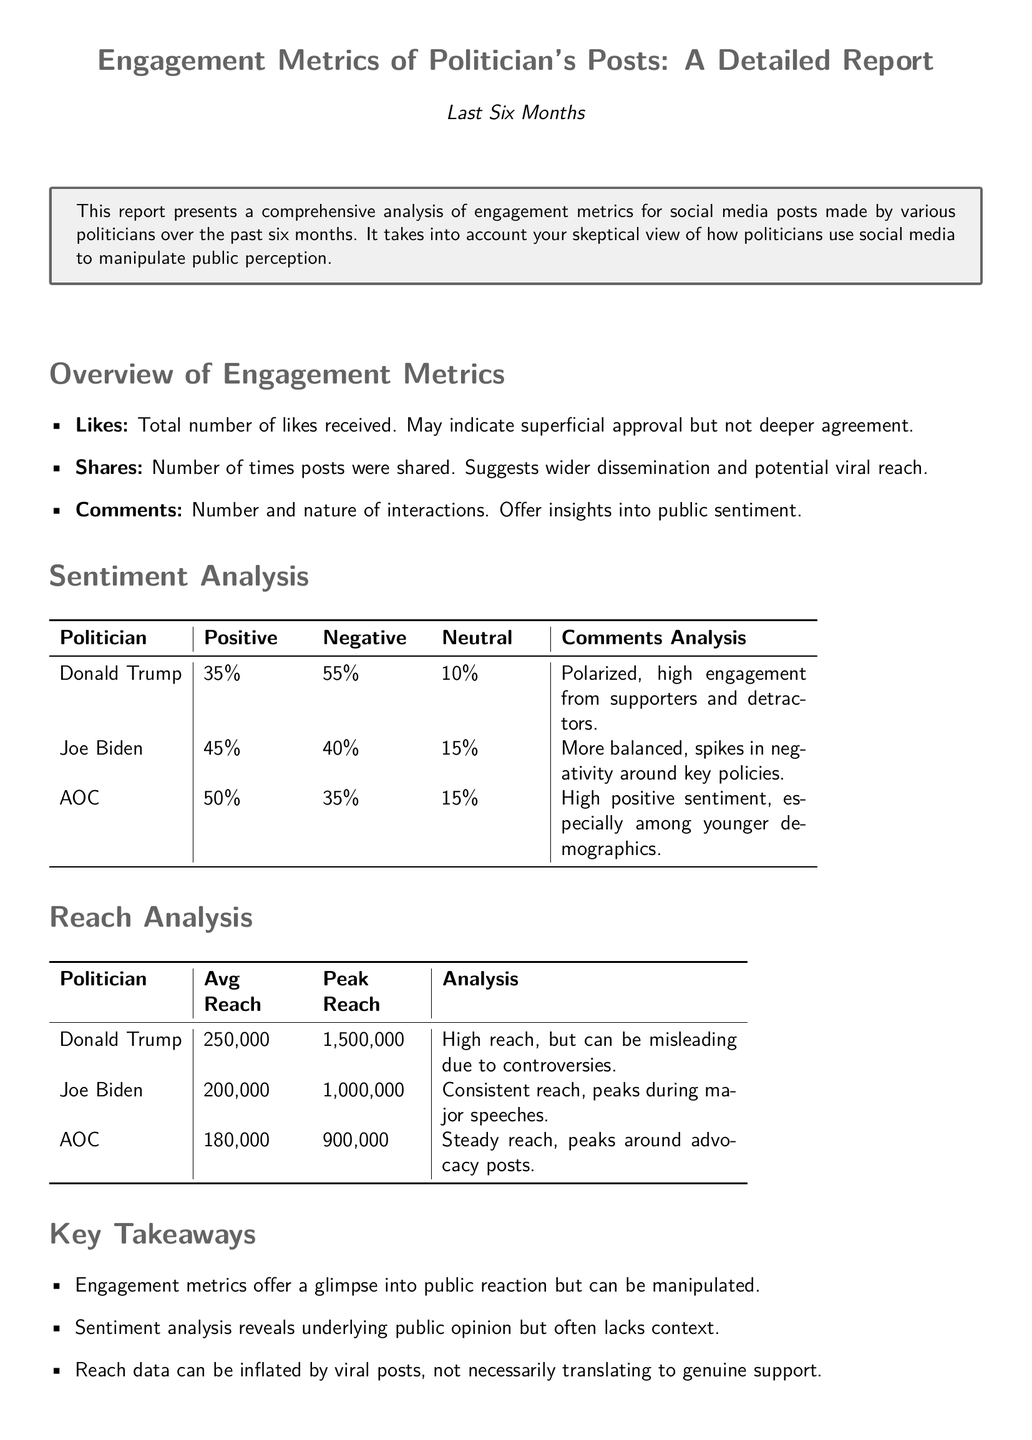what is the total percentage of positive sentiment for Joe Biden? The document states that Joe Biden has a positive sentiment of 45%.
Answer: 45% how many likes did Donald Trump receive on average? The document does not specify the average number of likes, only that he received a high engagement.
Answer: Not specified what is the peak reach for AOC? The peak reach for AOC is noted to be 900,000.
Answer: 900,000 what percentage of comments about Donald Trump are negative? The report indicates that 55% of comments about Donald Trump are negative.
Answer: 55% which politician had the highest average reach? The data shows that Donald Trump had the highest average reach at 250,000.
Answer: Donald Trump what is the engagement sentiment analysis for AOC? The analysis specifies that AOC has a high positive sentiment, especially among younger demographics.
Answer: High positive sentiment what is the neutral sentiment percentage for Joe Biden? According to the document, Joe Biden has a neutral sentiment percentage of 15%.
Answer: 15% what is the main drawback of the reach data mentioned? The document mentions that reach data can be misleading due to viral posts.
Answer: Misleading due to viral posts how does public sentiment towards Joe Biden spike? The report states that negativity spikes around key policies for Joe Biden.
Answer: Around key policies 